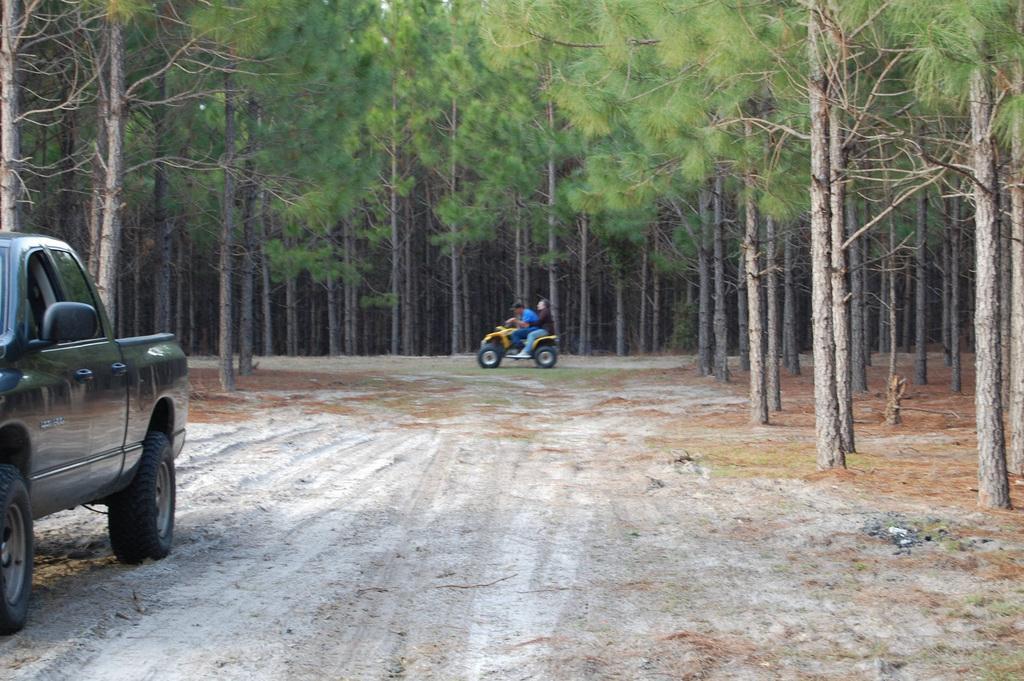Please provide a concise description of this image. In this image I can see the vehicle and I see two people are sitting on an another vehicle. In the background I can see many trees. 